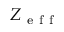Convert formula to latex. <formula><loc_0><loc_0><loc_500><loc_500>Z _ { e f f }</formula> 